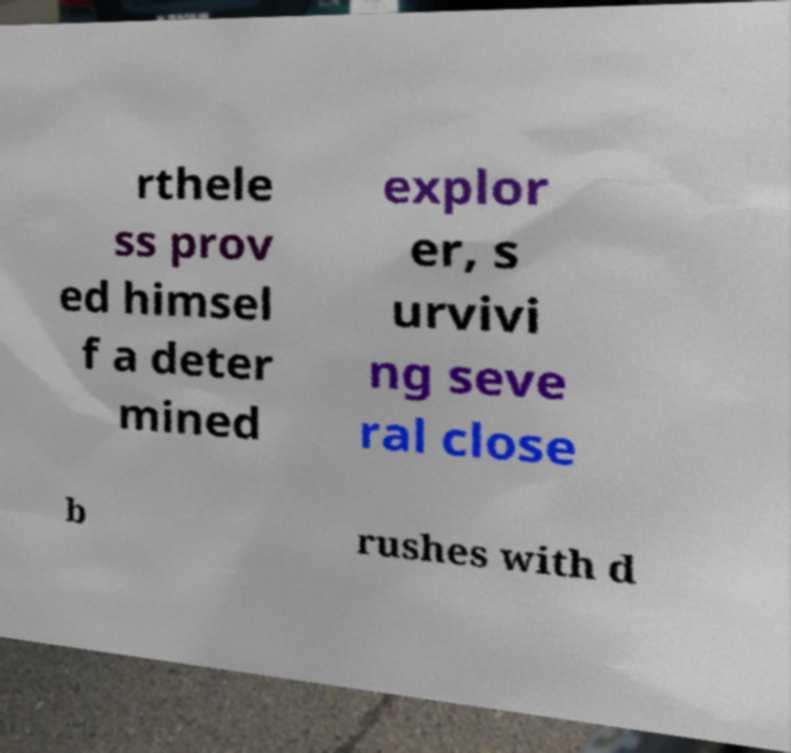Please read and relay the text visible in this image. What does it say? rthele ss prov ed himsel f a deter mined explor er, s urvivi ng seve ral close b rushes with d 